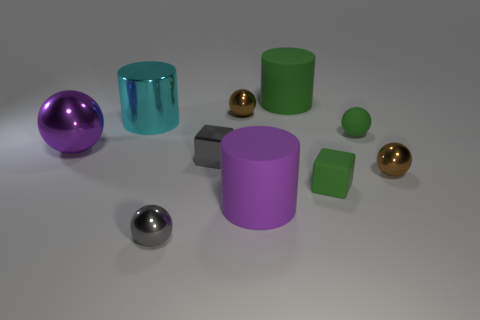Subtract all tiny green balls. How many balls are left? 4 Subtract all brown balls. How many balls are left? 3 Subtract all green spheres. Subtract all brown cubes. How many spheres are left? 4 Subtract all cylinders. How many objects are left? 7 Add 8 big yellow metallic cubes. How many big yellow metallic cubes exist? 8 Subtract 1 cyan cylinders. How many objects are left? 9 Subtract all tiny green matte things. Subtract all big purple metal balls. How many objects are left? 7 Add 6 tiny brown objects. How many tiny brown objects are left? 8 